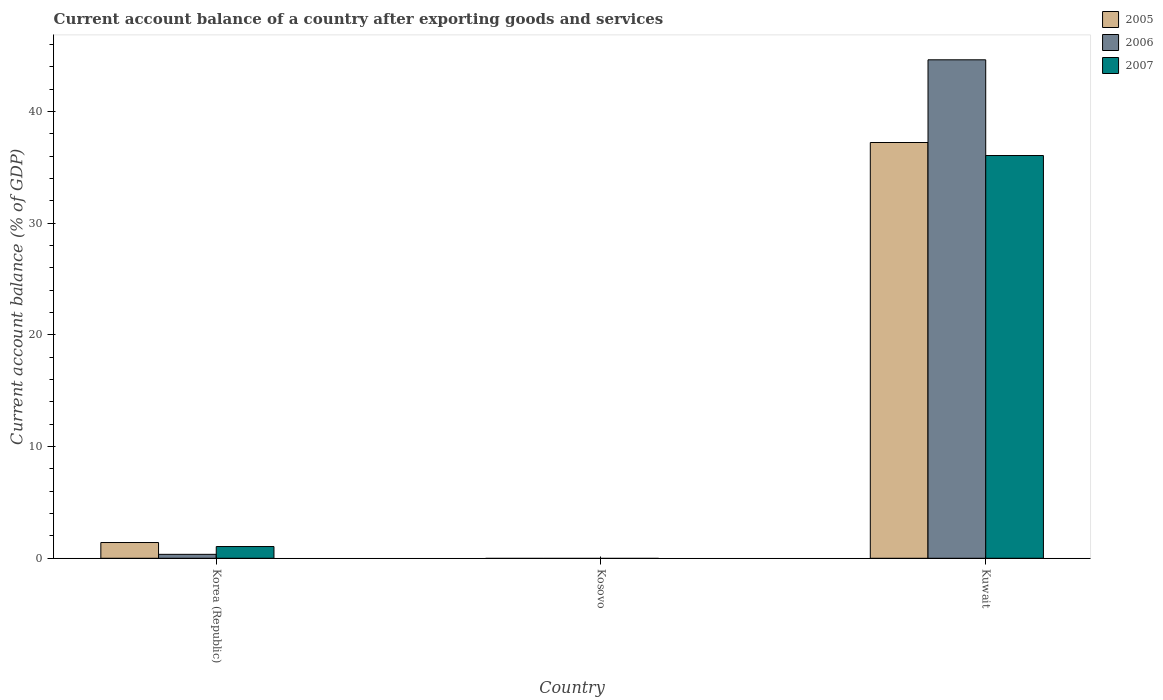Are the number of bars on each tick of the X-axis equal?
Your response must be concise. No. How many bars are there on the 2nd tick from the left?
Provide a succinct answer. 0. How many bars are there on the 2nd tick from the right?
Keep it short and to the point. 0. What is the label of the 3rd group of bars from the left?
Give a very brief answer. Kuwait. In how many cases, is the number of bars for a given country not equal to the number of legend labels?
Keep it short and to the point. 1. What is the account balance in 2007 in Korea (Republic)?
Offer a very short reply. 1.05. Across all countries, what is the maximum account balance in 2006?
Give a very brief answer. 44.62. Across all countries, what is the minimum account balance in 2005?
Your answer should be very brief. 0. In which country was the account balance in 2007 maximum?
Offer a very short reply. Kuwait. What is the total account balance in 2007 in the graph?
Offer a terse response. 37.1. What is the difference between the account balance in 2007 in Korea (Republic) and that in Kuwait?
Keep it short and to the point. -35. What is the difference between the account balance in 2007 in Kosovo and the account balance in 2005 in Korea (Republic)?
Offer a very short reply. -1.41. What is the average account balance in 2007 per country?
Provide a succinct answer. 12.37. What is the difference between the account balance of/in 2006 and account balance of/in 2007 in Korea (Republic)?
Provide a short and direct response. -0.7. What is the difference between the highest and the lowest account balance in 2007?
Your answer should be compact. 36.05. Is it the case that in every country, the sum of the account balance in 2006 and account balance in 2007 is greater than the account balance in 2005?
Your answer should be very brief. No. How many bars are there?
Your response must be concise. 6. How many countries are there in the graph?
Provide a short and direct response. 3. Does the graph contain any zero values?
Offer a very short reply. Yes. Where does the legend appear in the graph?
Offer a terse response. Top right. How many legend labels are there?
Keep it short and to the point. 3. How are the legend labels stacked?
Offer a terse response. Vertical. What is the title of the graph?
Offer a very short reply. Current account balance of a country after exporting goods and services. Does "2000" appear as one of the legend labels in the graph?
Keep it short and to the point. No. What is the label or title of the X-axis?
Offer a very short reply. Country. What is the label or title of the Y-axis?
Give a very brief answer. Current account balance (% of GDP). What is the Current account balance (% of GDP) in 2005 in Korea (Republic)?
Provide a succinct answer. 1.41. What is the Current account balance (% of GDP) in 2006 in Korea (Republic)?
Offer a terse response. 0.35. What is the Current account balance (% of GDP) in 2007 in Korea (Republic)?
Your answer should be compact. 1.05. What is the Current account balance (% of GDP) in 2006 in Kosovo?
Make the answer very short. 0. What is the Current account balance (% of GDP) of 2007 in Kosovo?
Ensure brevity in your answer.  0. What is the Current account balance (% of GDP) in 2005 in Kuwait?
Keep it short and to the point. 37.22. What is the Current account balance (% of GDP) of 2006 in Kuwait?
Your answer should be very brief. 44.62. What is the Current account balance (% of GDP) in 2007 in Kuwait?
Offer a terse response. 36.05. Across all countries, what is the maximum Current account balance (% of GDP) in 2005?
Ensure brevity in your answer.  37.22. Across all countries, what is the maximum Current account balance (% of GDP) of 2006?
Keep it short and to the point. 44.62. Across all countries, what is the maximum Current account balance (% of GDP) in 2007?
Give a very brief answer. 36.05. Across all countries, what is the minimum Current account balance (% of GDP) of 2005?
Ensure brevity in your answer.  0. What is the total Current account balance (% of GDP) in 2005 in the graph?
Keep it short and to the point. 38.63. What is the total Current account balance (% of GDP) in 2006 in the graph?
Offer a terse response. 44.97. What is the total Current account balance (% of GDP) of 2007 in the graph?
Your answer should be very brief. 37.1. What is the difference between the Current account balance (% of GDP) in 2005 in Korea (Republic) and that in Kuwait?
Your answer should be very brief. -35.81. What is the difference between the Current account balance (% of GDP) in 2006 in Korea (Republic) and that in Kuwait?
Keep it short and to the point. -44.27. What is the difference between the Current account balance (% of GDP) of 2007 in Korea (Republic) and that in Kuwait?
Ensure brevity in your answer.  -35. What is the difference between the Current account balance (% of GDP) of 2005 in Korea (Republic) and the Current account balance (% of GDP) of 2006 in Kuwait?
Provide a short and direct response. -43.21. What is the difference between the Current account balance (% of GDP) of 2005 in Korea (Republic) and the Current account balance (% of GDP) of 2007 in Kuwait?
Provide a succinct answer. -34.64. What is the difference between the Current account balance (% of GDP) in 2006 in Korea (Republic) and the Current account balance (% of GDP) in 2007 in Kuwait?
Give a very brief answer. -35.7. What is the average Current account balance (% of GDP) of 2005 per country?
Your answer should be very brief. 12.88. What is the average Current account balance (% of GDP) in 2006 per country?
Provide a short and direct response. 14.99. What is the average Current account balance (% of GDP) in 2007 per country?
Provide a short and direct response. 12.37. What is the difference between the Current account balance (% of GDP) in 2005 and Current account balance (% of GDP) in 2006 in Korea (Republic)?
Provide a succinct answer. 1.06. What is the difference between the Current account balance (% of GDP) of 2005 and Current account balance (% of GDP) of 2007 in Korea (Republic)?
Offer a terse response. 0.36. What is the difference between the Current account balance (% of GDP) in 2006 and Current account balance (% of GDP) in 2007 in Korea (Republic)?
Provide a short and direct response. -0.7. What is the difference between the Current account balance (% of GDP) in 2005 and Current account balance (% of GDP) in 2006 in Kuwait?
Keep it short and to the point. -7.4. What is the difference between the Current account balance (% of GDP) in 2005 and Current account balance (% of GDP) in 2007 in Kuwait?
Make the answer very short. 1.17. What is the difference between the Current account balance (% of GDP) of 2006 and Current account balance (% of GDP) of 2007 in Kuwait?
Offer a terse response. 8.57. What is the ratio of the Current account balance (% of GDP) of 2005 in Korea (Republic) to that in Kuwait?
Give a very brief answer. 0.04. What is the ratio of the Current account balance (% of GDP) in 2006 in Korea (Republic) to that in Kuwait?
Your answer should be very brief. 0.01. What is the ratio of the Current account balance (% of GDP) of 2007 in Korea (Republic) to that in Kuwait?
Keep it short and to the point. 0.03. What is the difference between the highest and the lowest Current account balance (% of GDP) in 2005?
Your answer should be very brief. 37.22. What is the difference between the highest and the lowest Current account balance (% of GDP) in 2006?
Your answer should be very brief. 44.62. What is the difference between the highest and the lowest Current account balance (% of GDP) of 2007?
Your response must be concise. 36.05. 